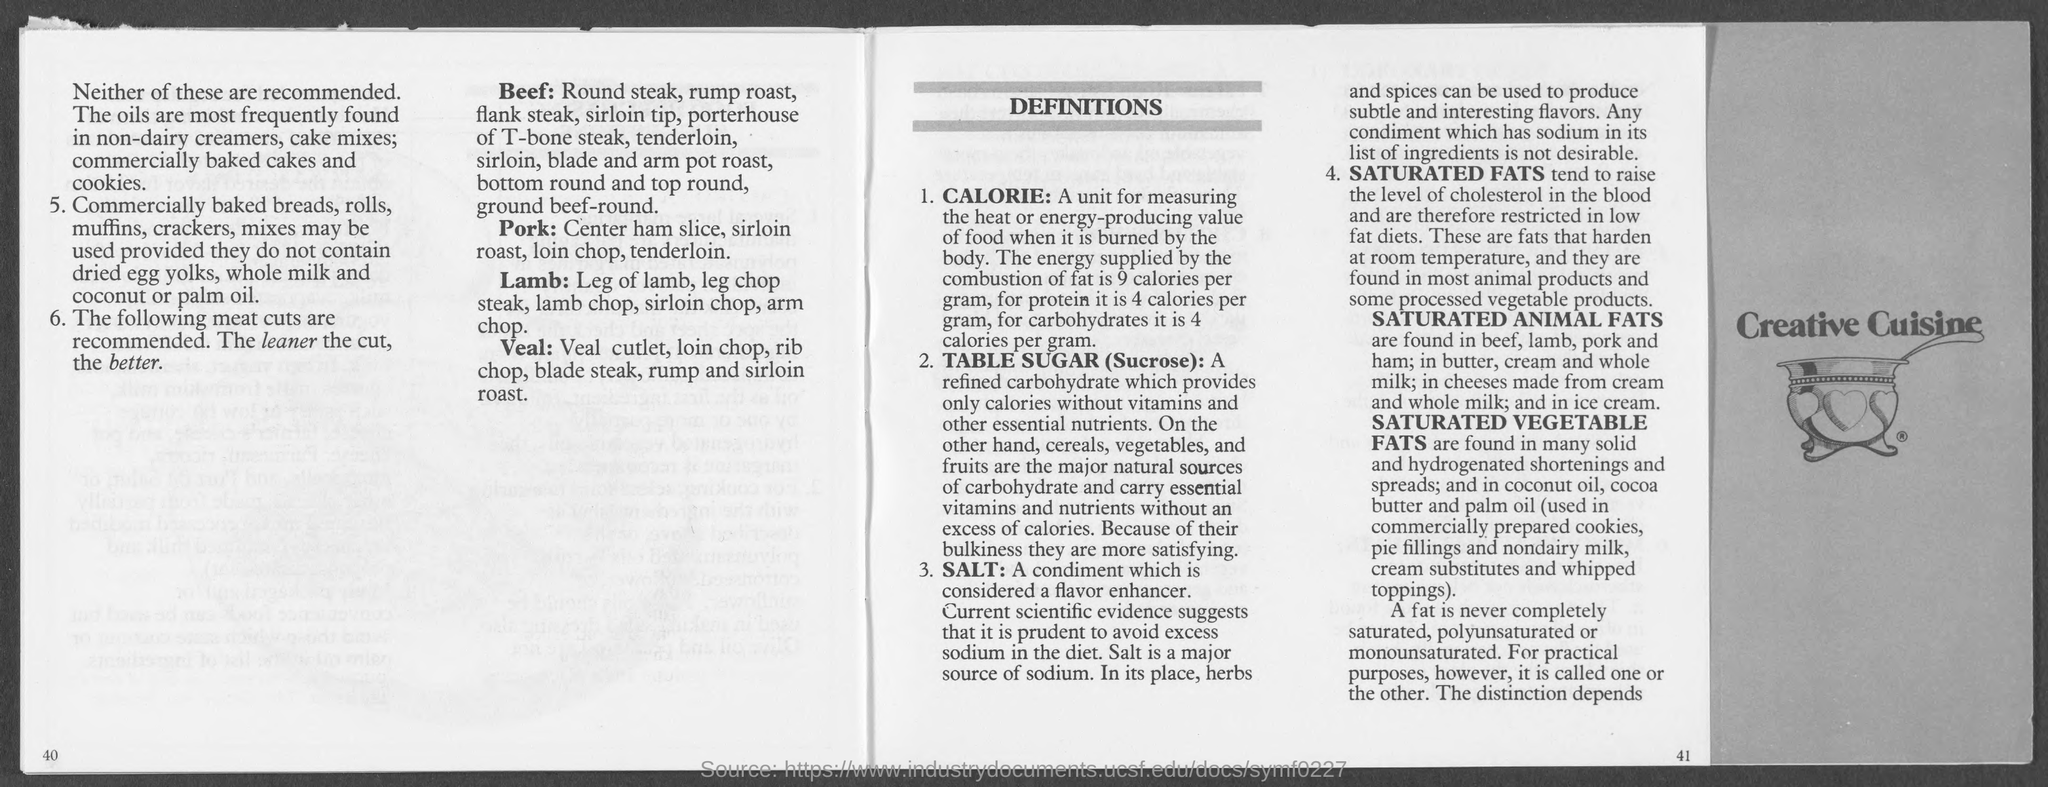Identify some key points in this picture. Salt is a flavor enhancer and condiment that is widely used to add flavor to food. Saturated fats are the types of fats that can increase the level of cholesterol in the blood. The combustion of proteins supplies 4 calories of energy. The combustion of fat supplies 9 calories per gram of energy. The combustion of carbohydrates supplies 4 calories per gram of energy. 